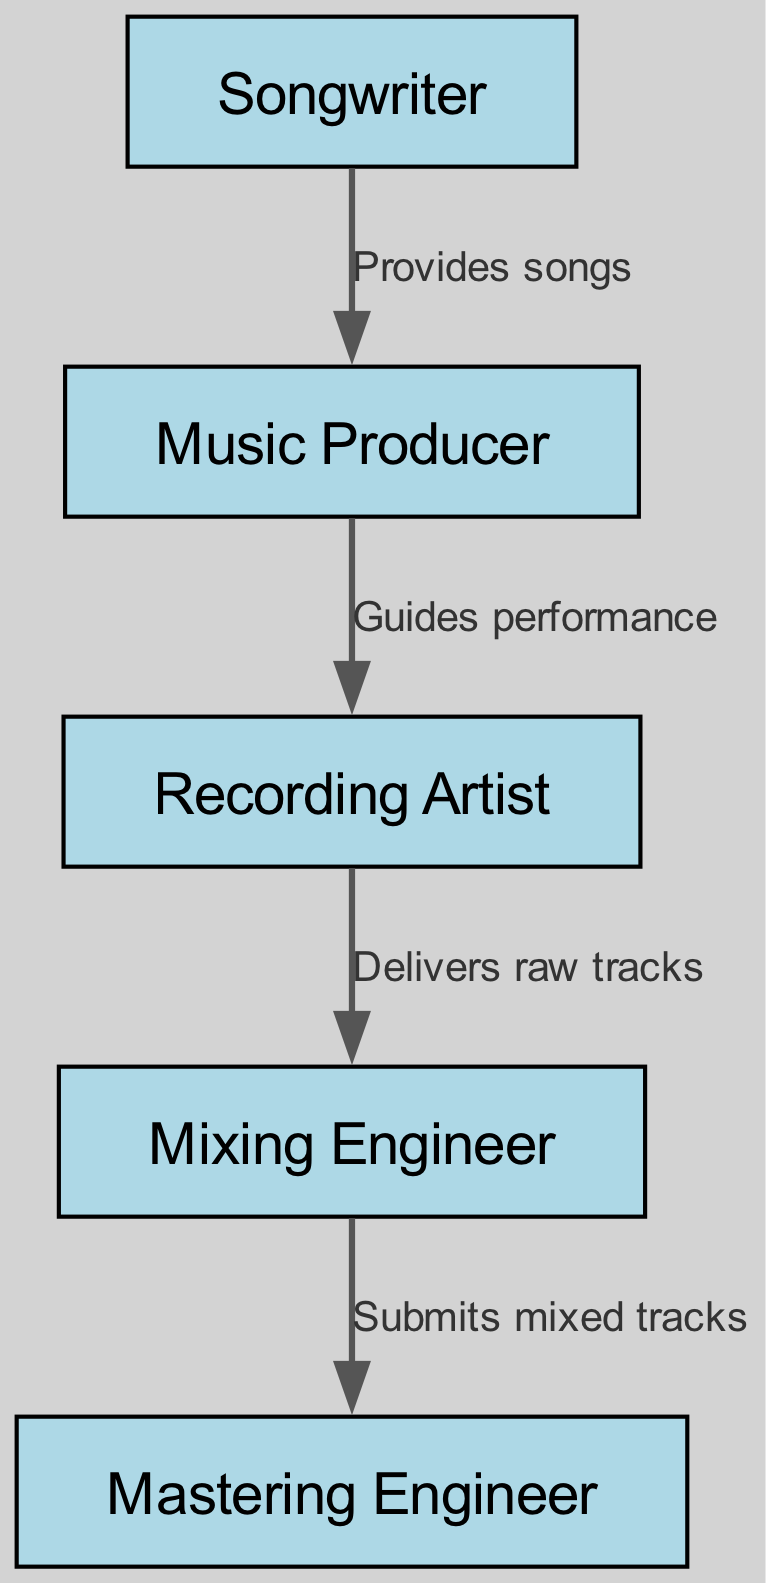What is the top node in the hierarchy? The diagram starts with the Songwriter at the top, as it is the first node and the initial contributor in the music production process.
Answer: Songwriter How many nodes are in the diagram? The total count of nodes can be found by listing them: Songwriter, Music Producer, Recording Artist, Mixing Engineer, and Mastering Engineer, which gives a total of five nodes.
Answer: 5 Who does the Mixing Engineer receive tracks from? The edge from Recording Artist to Mixing Engineer indicates that the Mixing Engineer receives the raw tracks directly from the Recording Artist.
Answer: Recording Artist What role provides songs to the Music Producer? The edge from Songwriter to Music Producer shows that the Songwriter is the one who provides the songs, establishing a clear relationship between these two nodes.
Answer: Songwriter Which node submits mixed tracks to the Mastering Engineer? The diagram shows an edge from Mixing Engineer to Mastering Engineer, indicating that the Mixing Engineer submits the mixed tracks to the Mastering Engineer.
Answer: Mixing Engineer What is the role of the Music Producer in this hierarchy? The edge from Music Producer to Recording Artist indicates that the Music Producer guides the performance of the Recording Artist within this hierarchy, meaning the Producer's job is to help shape the artist's sound.
Answer: Guides performance How many edges are present in the diagram? To find the number of edges, we can count the provided relationships: from Songwriter to Producer, from Producer to Artist, from Artist to Mixer, and from Mixer to Mastering, which totals to four edges.
Answer: 4 What is the relationship between the Artist and the Mixer? The edge from Recording Artist to Mixing Engineer defines the relationship where the Artist delivers raw tracks to the Mixer for processing, highlighting their collaborative role.
Answer: Delivers raw tracks Who guides the performance of the Recording Artist? The Music Producer is the role that guides the performance, as indicated by the edge connecting the Producer to the Artist.
Answer: Music Producer 